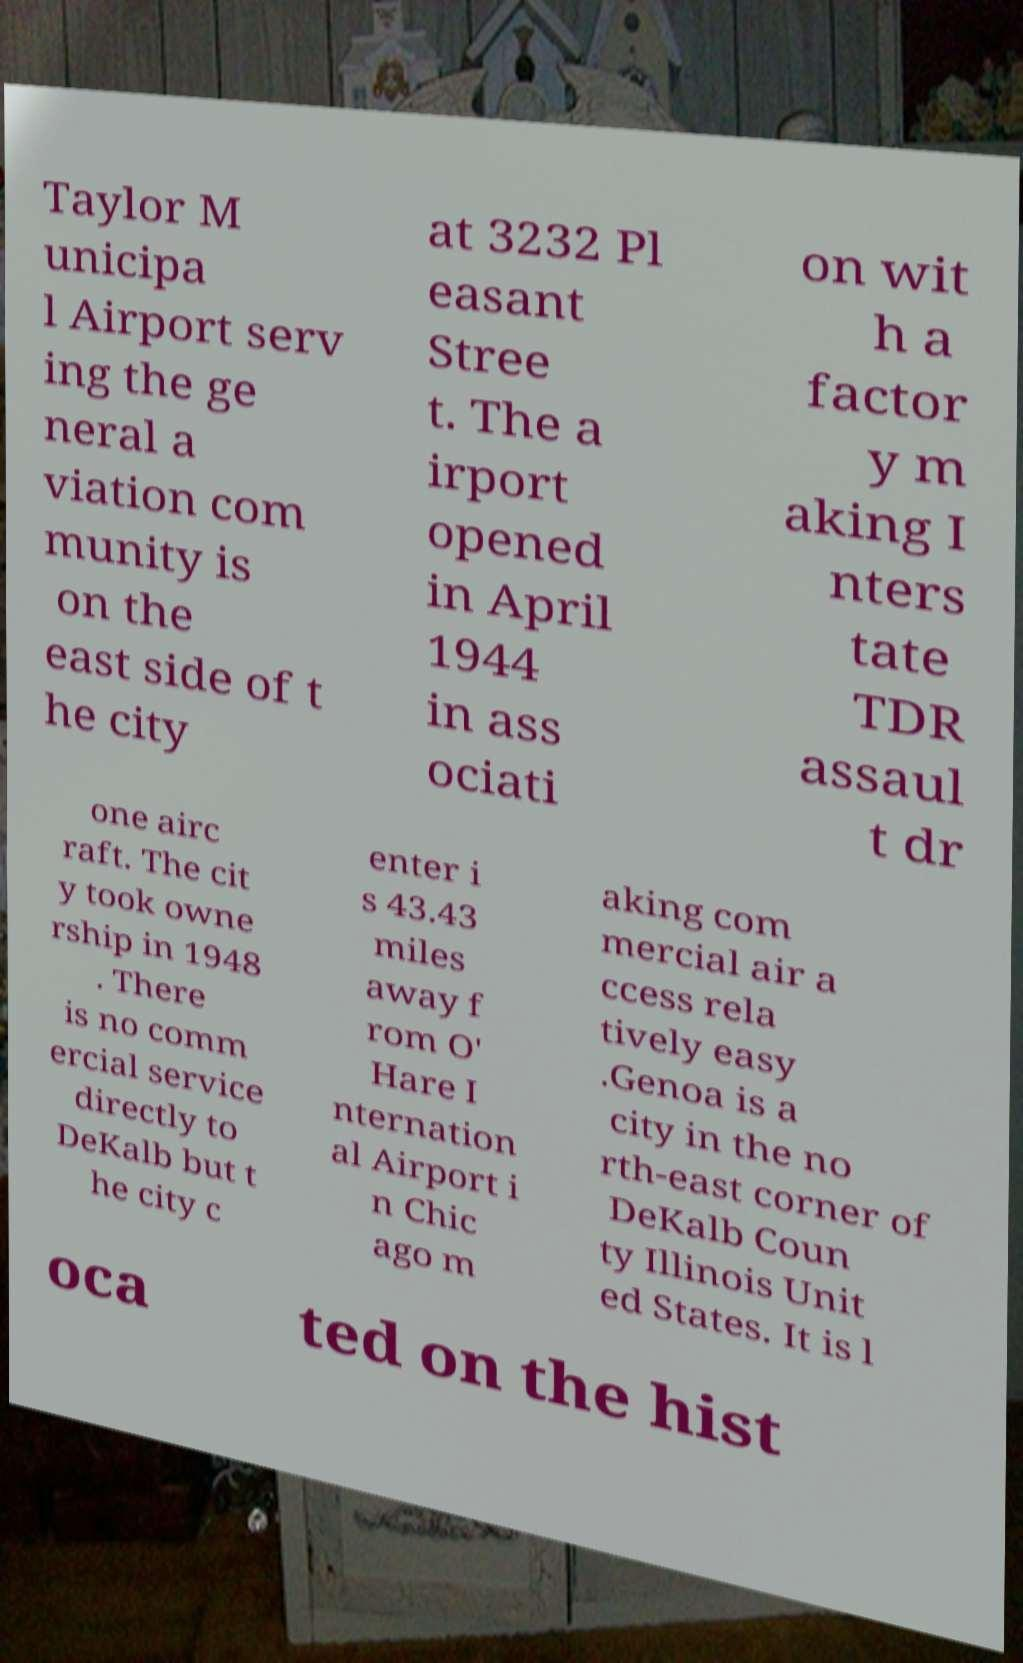For documentation purposes, I need the text within this image transcribed. Could you provide that? Taylor M unicipa l Airport serv ing the ge neral a viation com munity is on the east side of t he city at 3232 Pl easant Stree t. The a irport opened in April 1944 in ass ociati on wit h a factor y m aking I nters tate TDR assaul t dr one airc raft. The cit y took owne rship in 1948 . There is no comm ercial service directly to DeKalb but t he city c enter i s 43.43 miles away f rom O' Hare I nternation al Airport i n Chic ago m aking com mercial air a ccess rela tively easy .Genoa is a city in the no rth-east corner of DeKalb Coun ty Illinois Unit ed States. It is l oca ted on the hist 